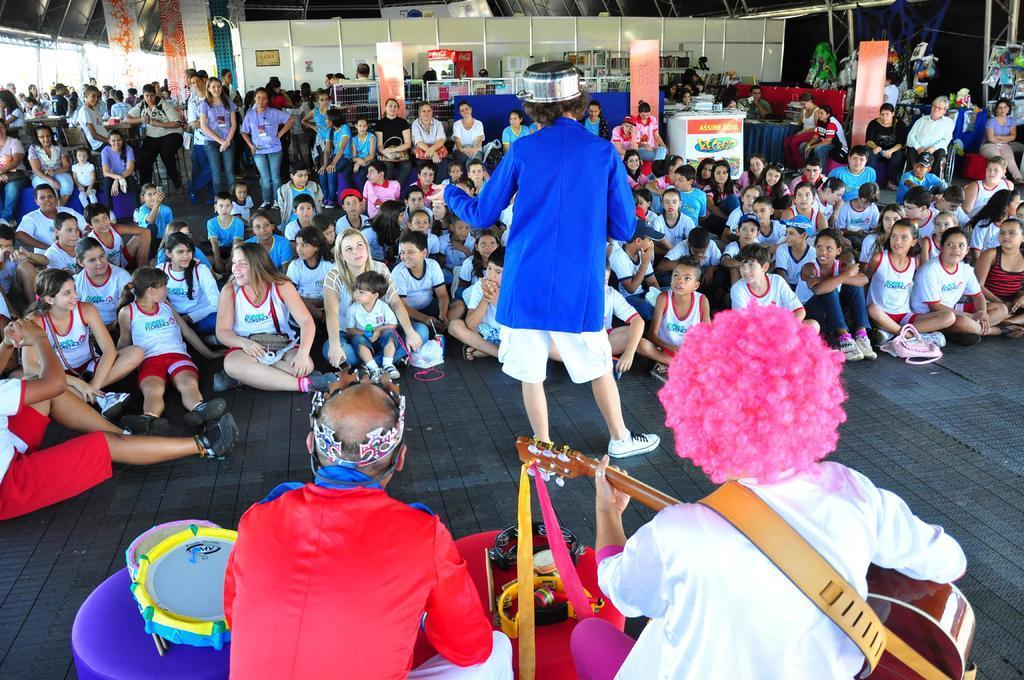Describe this image in one or two sentences. There is a person in red color shirt, sitting on a stool near drums and a person who is in white color shirt, sitting on a stool, holding a guitar and playing. In front of them, there is a person in blue color shirt standing on the floor on which, there are persons in different color dresses sitting. Some of them are smiling. In the background, there are persons standing and there are persons sitting on chairs, there is wall and there are other objects. 